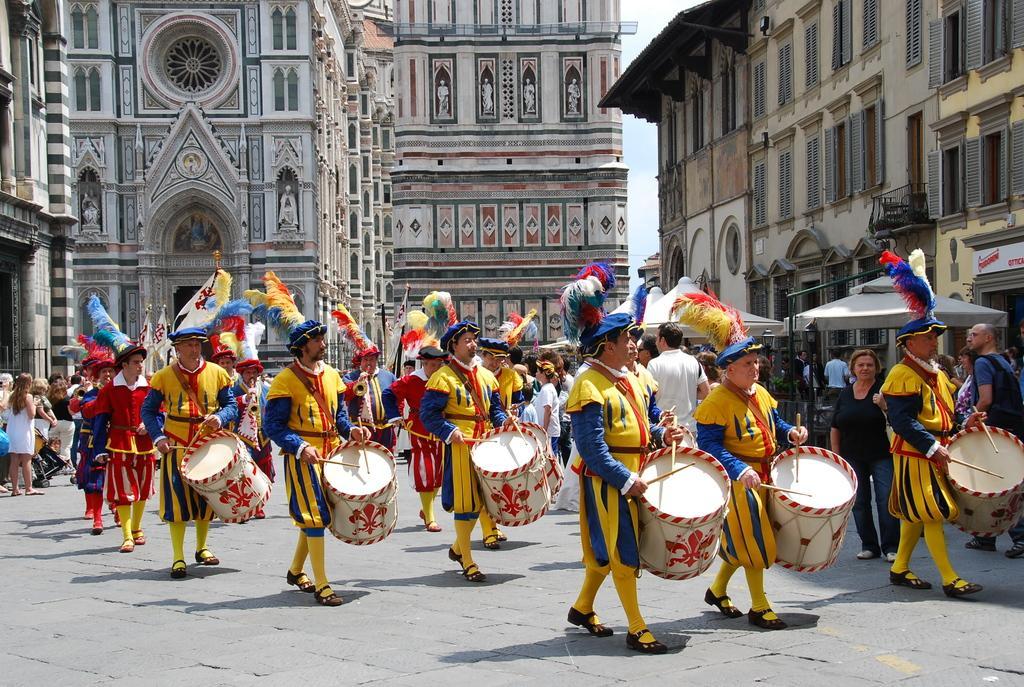In one or two sentences, can you explain what this image depicts? In this image, there are many persons playing drums. All are wearing yellow dress. In the background, there are buildings. To the right, there are windows and a tent. 